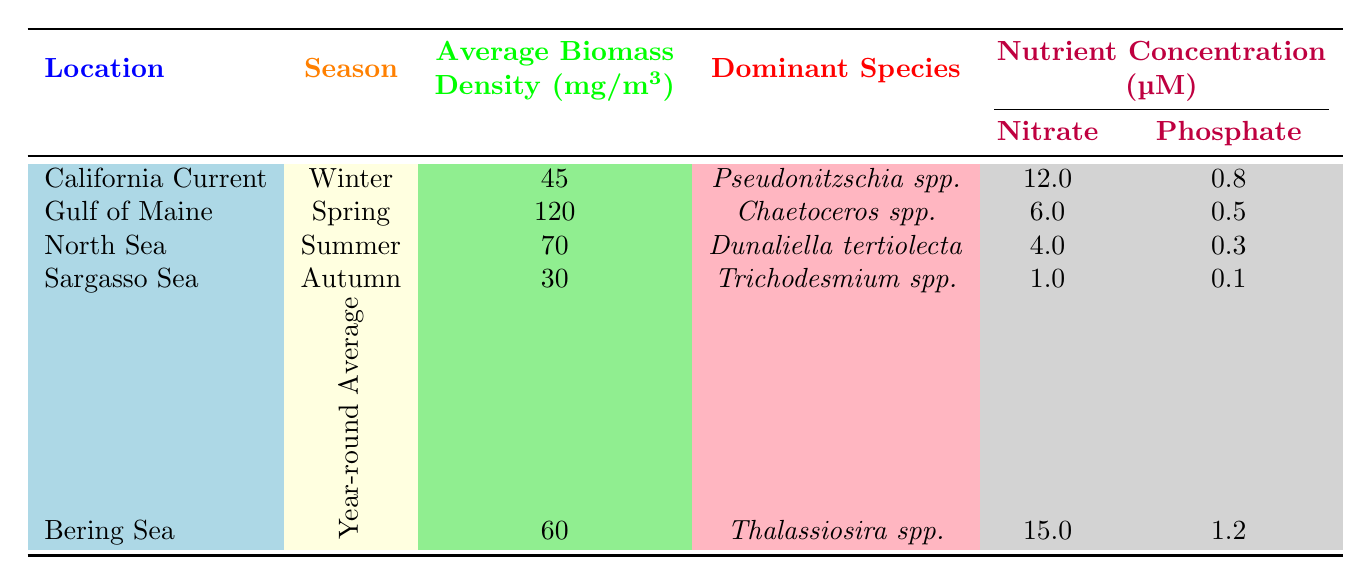What is the average biomass density of phytoplankton in the Gulf of Maine during Spring? Referring to the table, the average biomass density in the Gulf of Maine during Spring is directly stated as 120 mg/m3.
Answer: 120 mg/m3 Which location has the highest average biomass density and what is that value? The table shows the average biomass densities for each location. The highest value is 120 mg/m3, found in the Gulf of Maine during Spring.
Answer: Gulf of Maine, 120 mg/m3 What is the dominant species in the California Current during Winter? The table directly lists the dominant species in the California Current during Winter as Pseudonitzschia spp.
Answer: Pseudonitzschia spp Is the Nitrate concentration in the Sargasso Sea higher than in the North Sea? Looking at the nitrate concentrations, Sargasso Sea has 1.0 µM and North Sea has 4.0 µM. Since 1.0 is not greater than 4.0, the statement is false.
Answer: No Calculate the total average biomass density from Summer and Autumn locations. From the table, the average biomass density for Summer (North Sea) is 70 mg/m3 and for Autumn (Sargasso Sea) is 30 mg/m3. Adding these together gives 70 + 30 = 100 mg/m3.
Answer: 100 mg/m3 Does the nutrient concentration of Phosphate during Winter in the California Current exceed 0.5 µM? The Phosphate concentration in the California Current during Winter is listed as 0.8 µM, which is greater than 0.5 µM. Thus, the statement is true.
Answer: Yes Which season corresponds to the dominant species Chaetoceros spp.? The table indicates that Chaetoceros spp. is the dominant species during the Spring in the Gulf of Maine.
Answer: Spring What is the total nitrate concentration for all locations during the specific seasons reported? Adding the nitrate concentrations from the table: 12 (California Current) + 6 (Gulf of Maine) + 4 (North Sea) + 1 (Sargasso Sea) + 15 (Bering Sea) gives a total of 38 µM.
Answer: 38 µM Which location shows the lowest average biomass density and what is the value? Reviewing the table, Sargasso Sea is identified as having the lowest average biomass density at 30 mg/m3.
Answer: Sargasso Sea, 30 mg/m3 